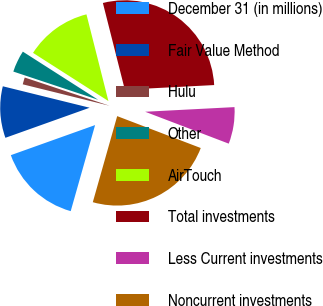Convert chart to OTSL. <chart><loc_0><loc_0><loc_500><loc_500><pie_chart><fcel>December 31 (in millions)<fcel>Fair Value Method<fcel>Hulu<fcel>Other<fcel>AirTouch<fcel>Total investments<fcel>Less Current investments<fcel>Noncurrent investments<nl><fcel>15.15%<fcel>9.31%<fcel>1.26%<fcel>3.94%<fcel>12.0%<fcel>28.12%<fcel>6.63%<fcel>23.59%<nl></chart> 